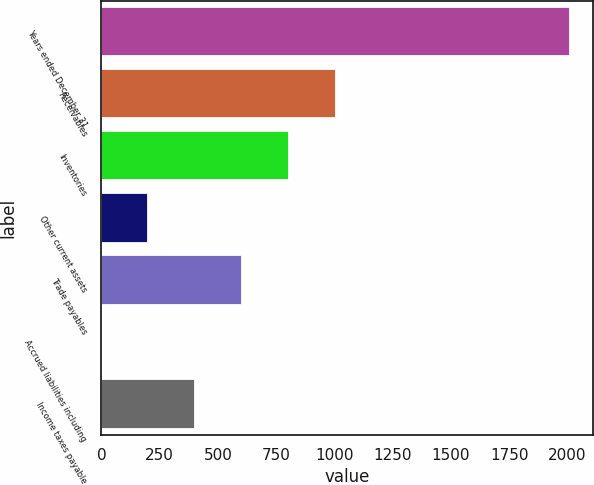<chart> <loc_0><loc_0><loc_500><loc_500><bar_chart><fcel>Years ended December 31<fcel>Receivables<fcel>Inventories<fcel>Other current assets<fcel>Trade payables<fcel>Accrued liabilities including<fcel>Income taxes payable<nl><fcel>2010<fcel>1005.35<fcel>804.42<fcel>201.63<fcel>603.49<fcel>0.7<fcel>402.56<nl></chart> 